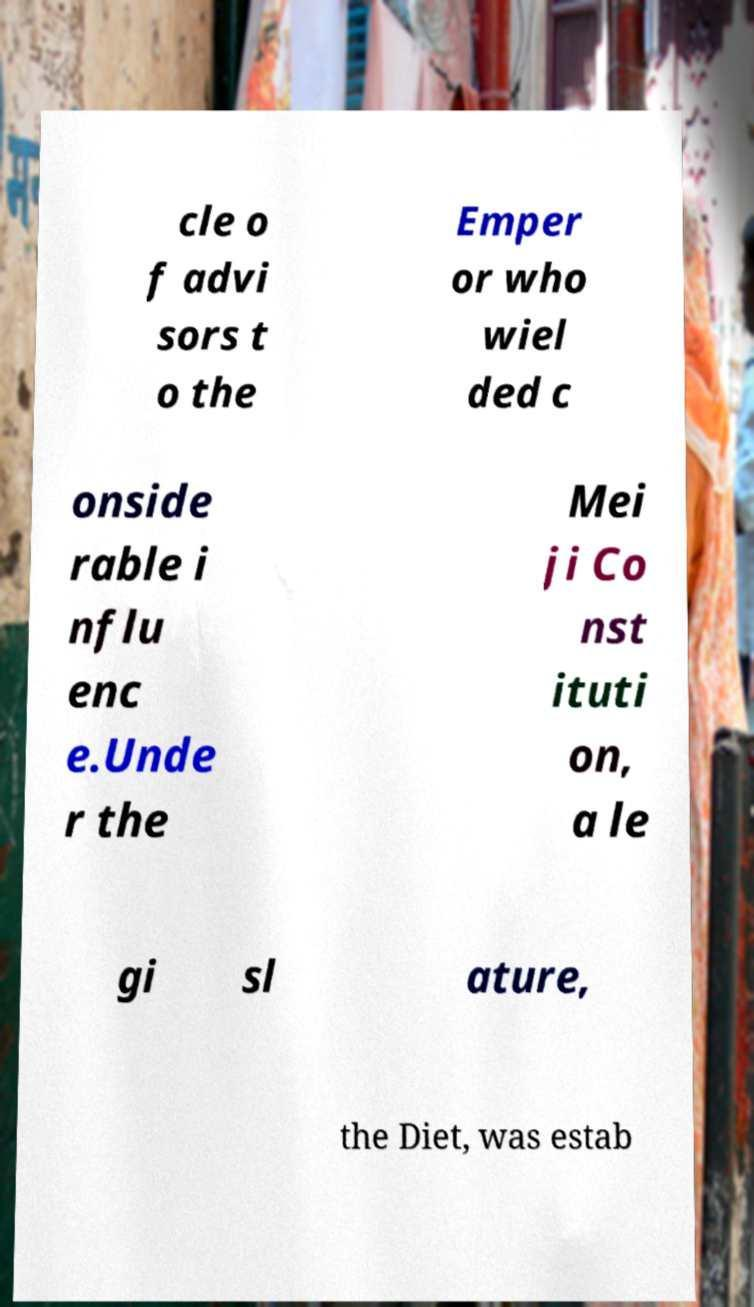For documentation purposes, I need the text within this image transcribed. Could you provide that? cle o f advi sors t o the Emper or who wiel ded c onside rable i nflu enc e.Unde r the Mei ji Co nst ituti on, a le gi sl ature, the Diet, was estab 